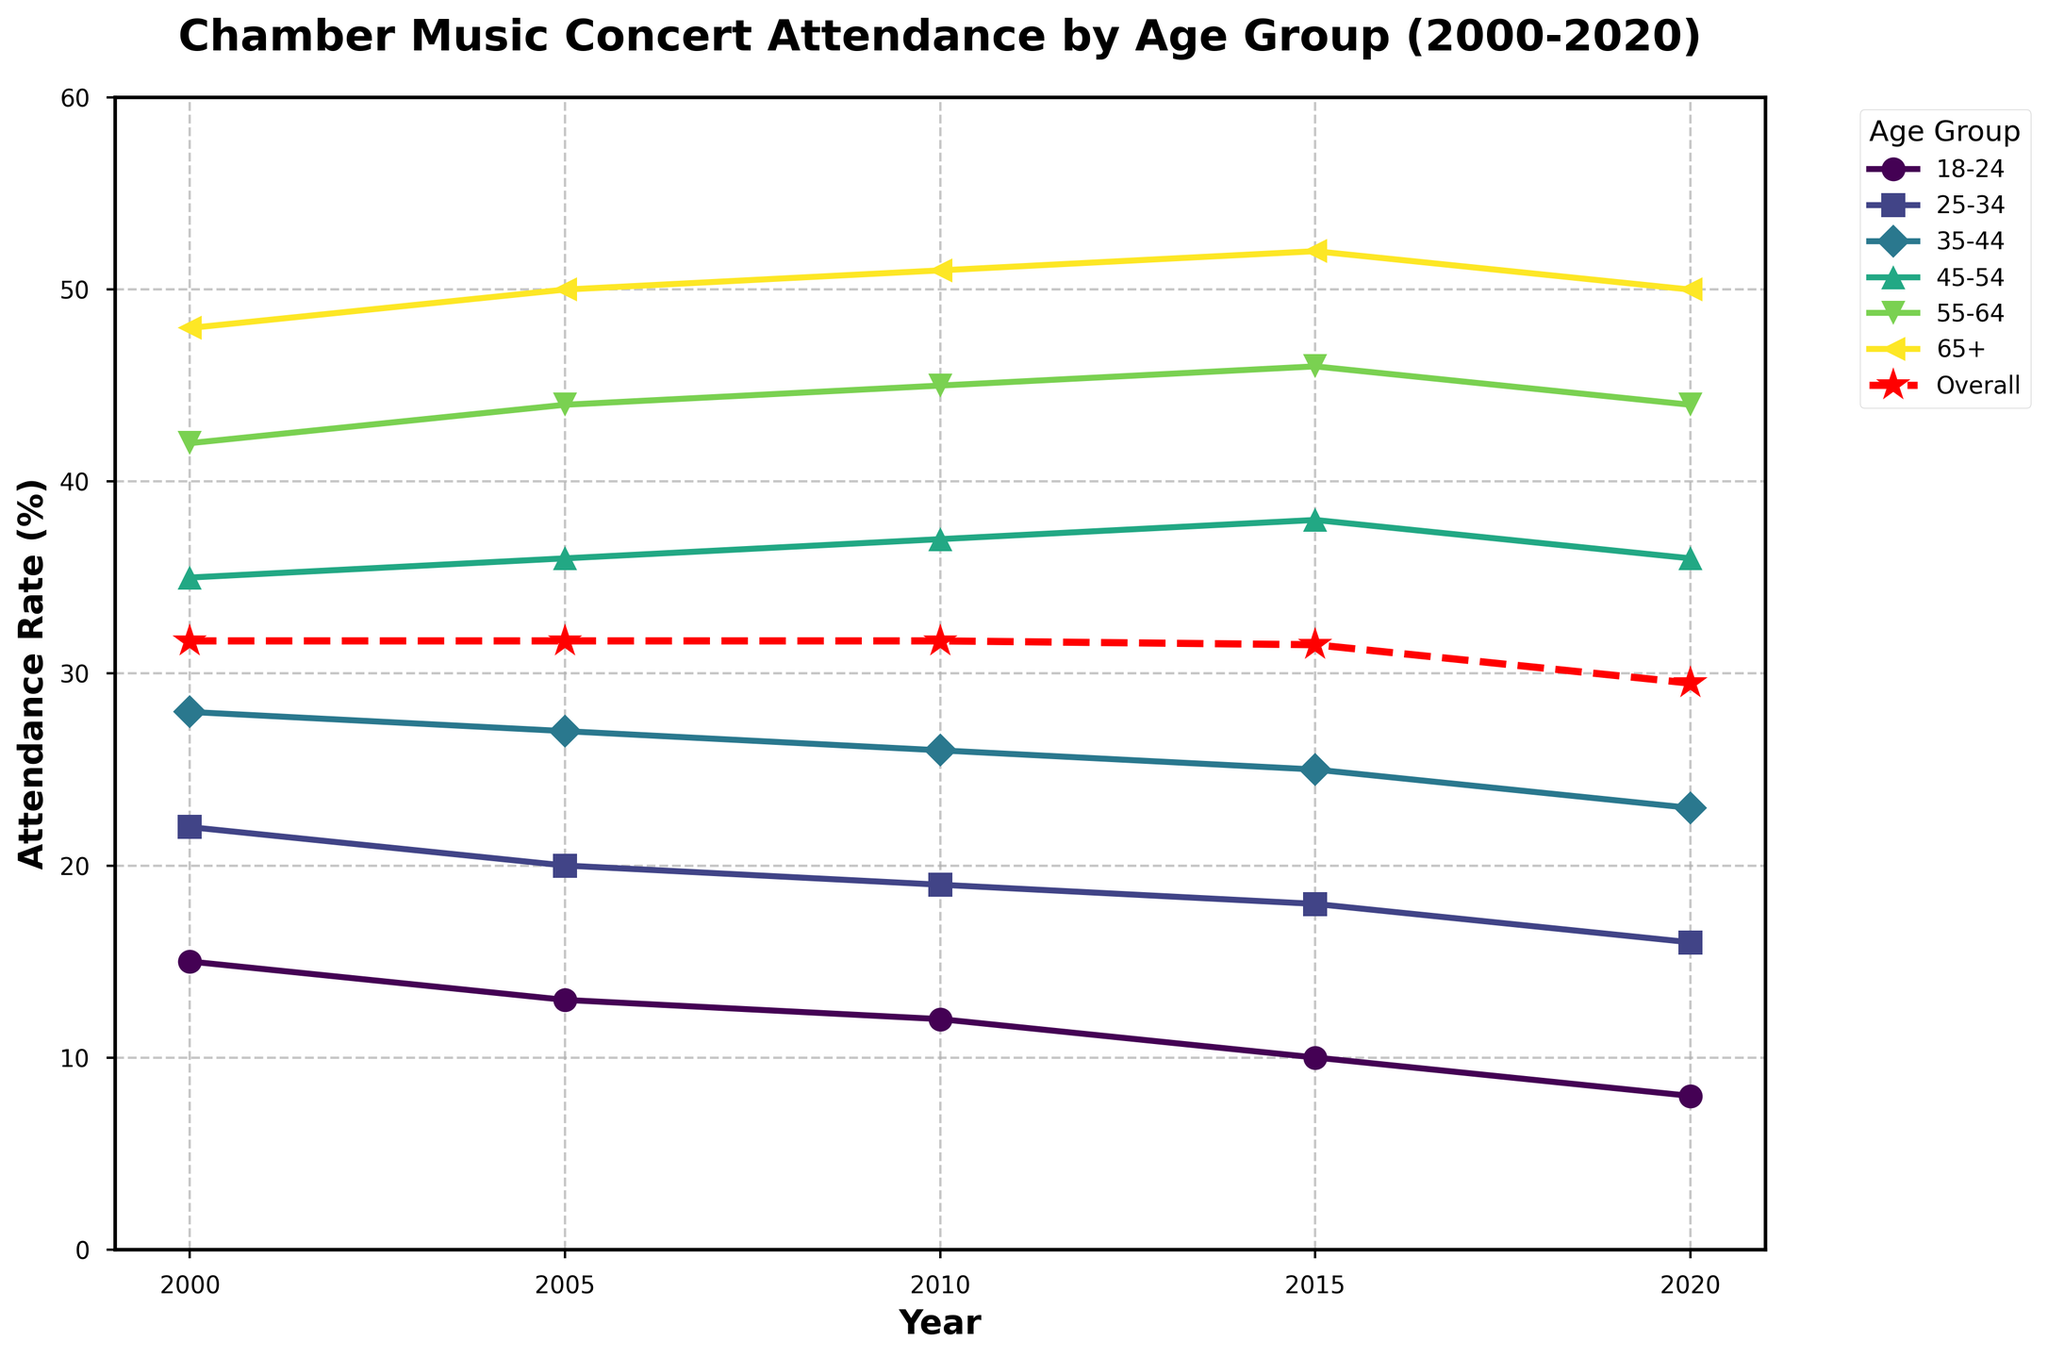What's the attendance rate trend for the 18-24 age group from 2000 to 2020? To determine the trend, we look at the points representing the 18-24 age group over the years 2000, 2005, 2010, 2015, and 2020. The attendance rate decreases from 15% in 2000 to 8% in 2020.
Answer: Decreasing Which age group had the highest attendance rate in 2015? We compare the attendance rates of all age groups in the year 2015. The 65+ age group has the highest rate at 52%.
Answer: 65+ How did the overall attendance rate change from 2010 to 2020? We look at the overall attendance rates for the years 2010 and 2020. The rate decreases from 31.7% in 2010 to 29.5% in 2020, implying a decrease of 2.2%.
Answer: Decreased by 2.2% Which age group saw the least change in attendance rates from 2000 to 2020? We find the difference in attendance rates from 2000 to 2020 for each age group. The 35-44 age group changes from 28% to 23%, a difference of 5%, which is the smallest change among all age groups.
Answer: 35-44 What's the average attendance rate for the 55-64 age group across all years presented? We calculate the average by summing the attendance rates for the 55-64 age group across 2000, 2005, 2010, 2015, and 2020 and then dividing by 5. The average is (42+44+45+46+44)/5 = 44.2%.
Answer: 44.2% Did any age group experience an increase in attendance from 2000 to 2015? Examining the attendance rates for each age group from 2000 to 2015, the 45-54 and 55-64 age groups both show an increase. For instance, the 45-54 age group increases from 35% to 38%.
Answer: Yes, 45-54 and 55-64 What is the difference in attendance rates between the 25-34 and 65+ age groups in 2020? We find the attendance rates for the 25-34 age group and 65+ age group in 2020, which are 16% and 50%, respectively. The difference is 50% - 16% = 34%.
Answer: 34% Which age group had a steadier trend, 35-44 or 55-64, from 2000 to 2020? By visually inspecting the lines representing both age groups, we observe the visual fluctuations. The 35-44 age group shows a consistent decrease, whereas the 55-64 age group shows slight variability but generally increases. Thus, 35-44 exhibits a steadier trend.
Answer: 35-44 